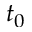Convert formula to latex. <formula><loc_0><loc_0><loc_500><loc_500>t _ { 0 }</formula> 